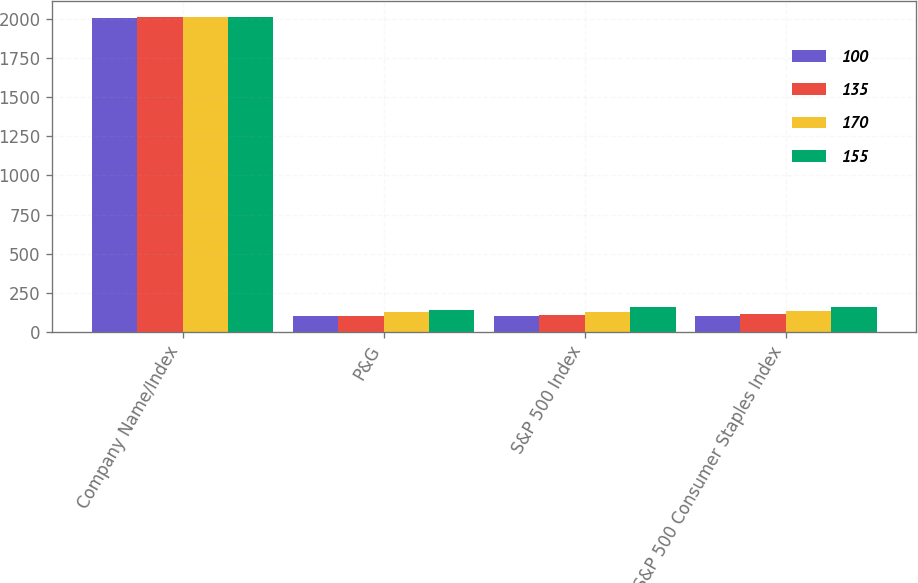Convert chart to OTSL. <chart><loc_0><loc_0><loc_500><loc_500><stacked_bar_chart><ecel><fcel>Company Name/Index<fcel>P&G<fcel>S&P 500 Index<fcel>S&P 500 Consumer Staples Index<nl><fcel>100<fcel>2011<fcel>100<fcel>100<fcel>100<nl><fcel>135<fcel>2012<fcel>100<fcel>105<fcel>115<nl><fcel>170<fcel>2013<fcel>129<fcel>127<fcel>135<nl><fcel>155<fcel>2014<fcel>136<fcel>158<fcel>155<nl></chart> 